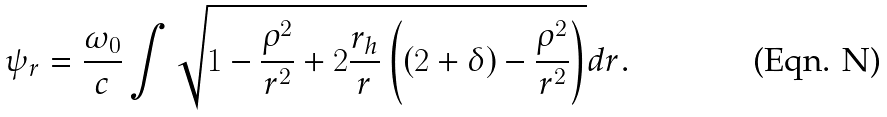Convert formula to latex. <formula><loc_0><loc_0><loc_500><loc_500>\psi _ { r } = \frac { \omega _ { 0 } } { c } \int \sqrt { 1 - \frac { \rho ^ { 2 } } { r ^ { 2 } } + 2 \frac { r _ { h } } { r } \left ( ( 2 + \delta ) - \frac { \rho ^ { 2 } } { r ^ { 2 } } \right ) } d r .</formula> 